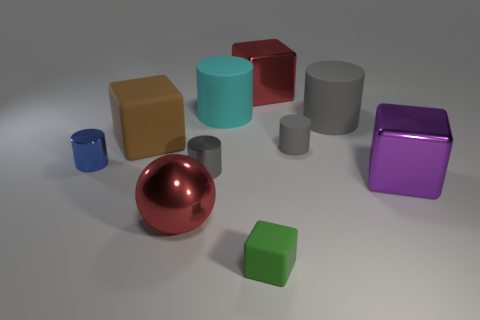Subtract all purple spheres. How many gray cylinders are left? 3 Subtract all cyan cylinders. How many cylinders are left? 4 Subtract 1 blocks. How many blocks are left? 3 Subtract all cyan cylinders. How many cylinders are left? 4 Subtract all purple cylinders. Subtract all yellow cubes. How many cylinders are left? 5 Subtract all blocks. How many objects are left? 6 Add 1 large red objects. How many large red objects are left? 3 Add 1 big yellow matte spheres. How many big yellow matte spheres exist? 1 Subtract 1 blue cylinders. How many objects are left? 9 Subtract all cylinders. Subtract all small rubber things. How many objects are left? 3 